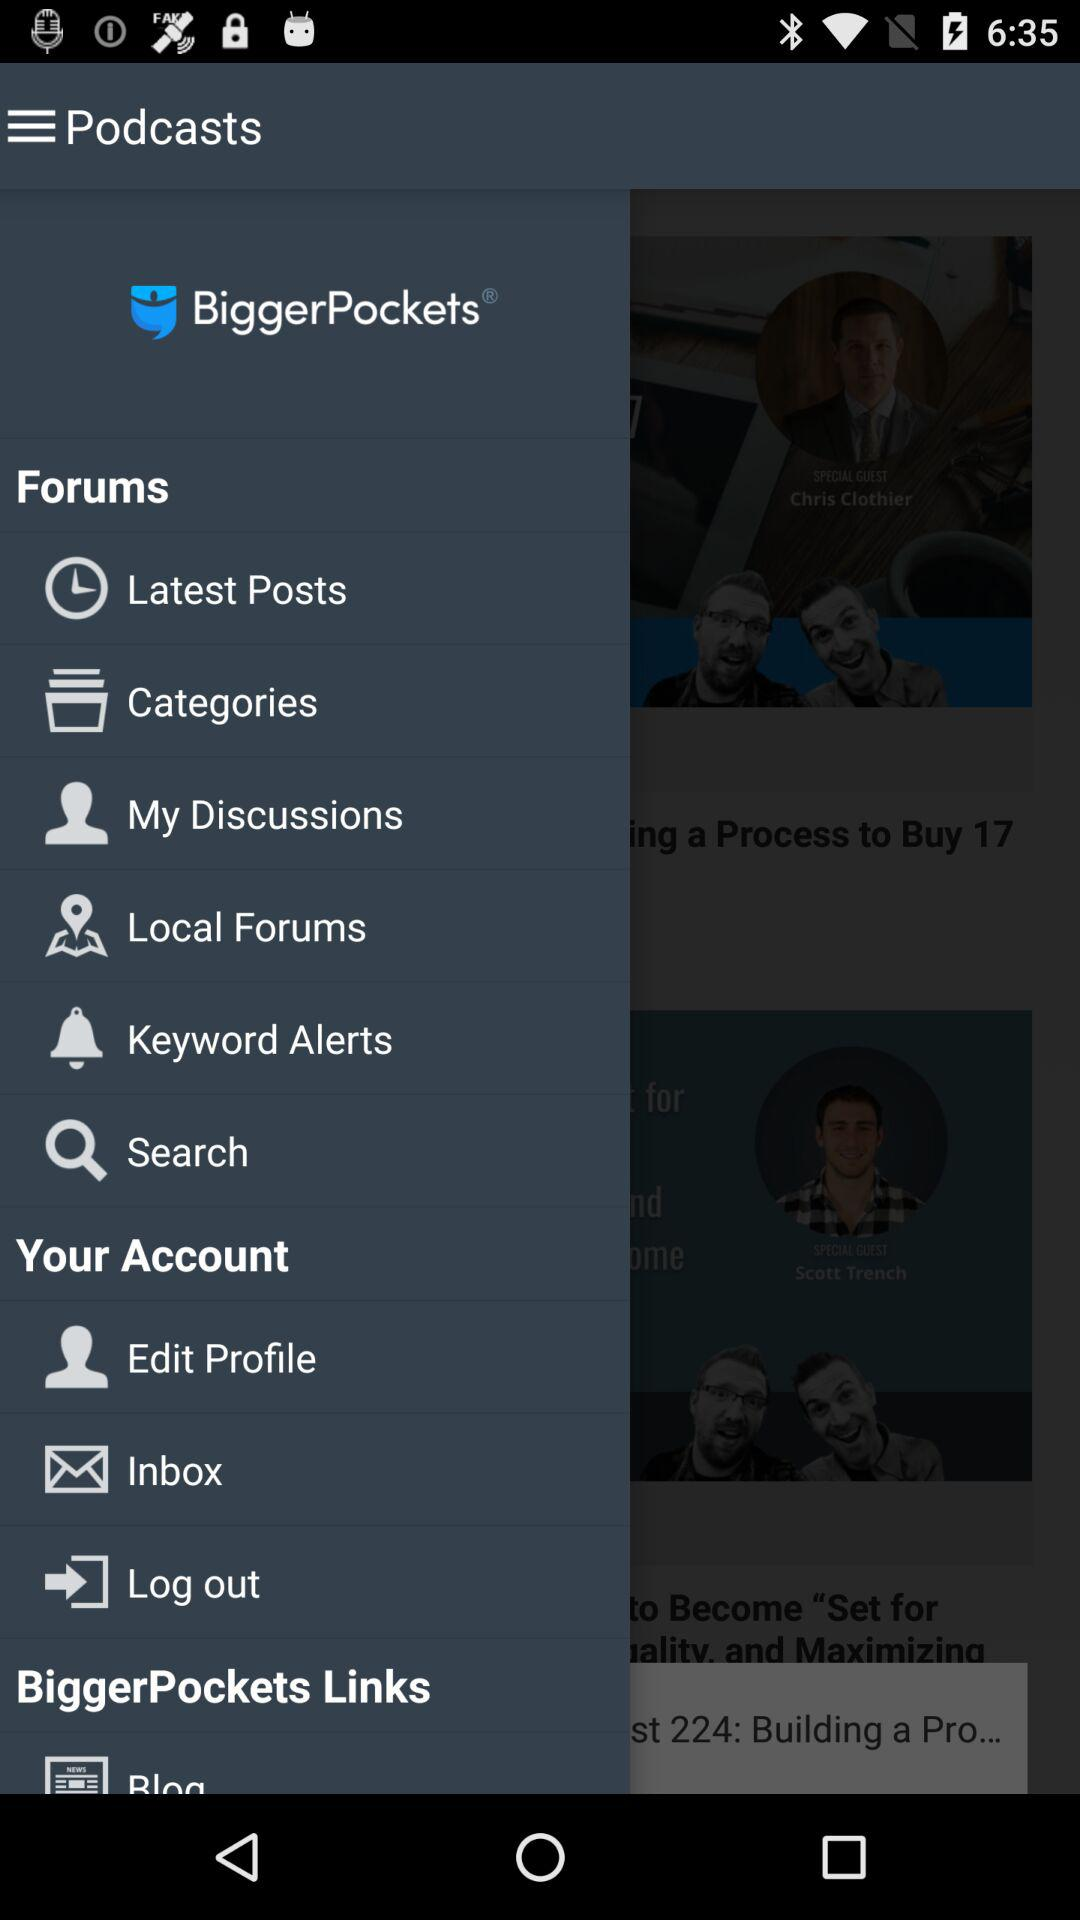What is the name of the application? The name of the application is "BiggerPockets". 